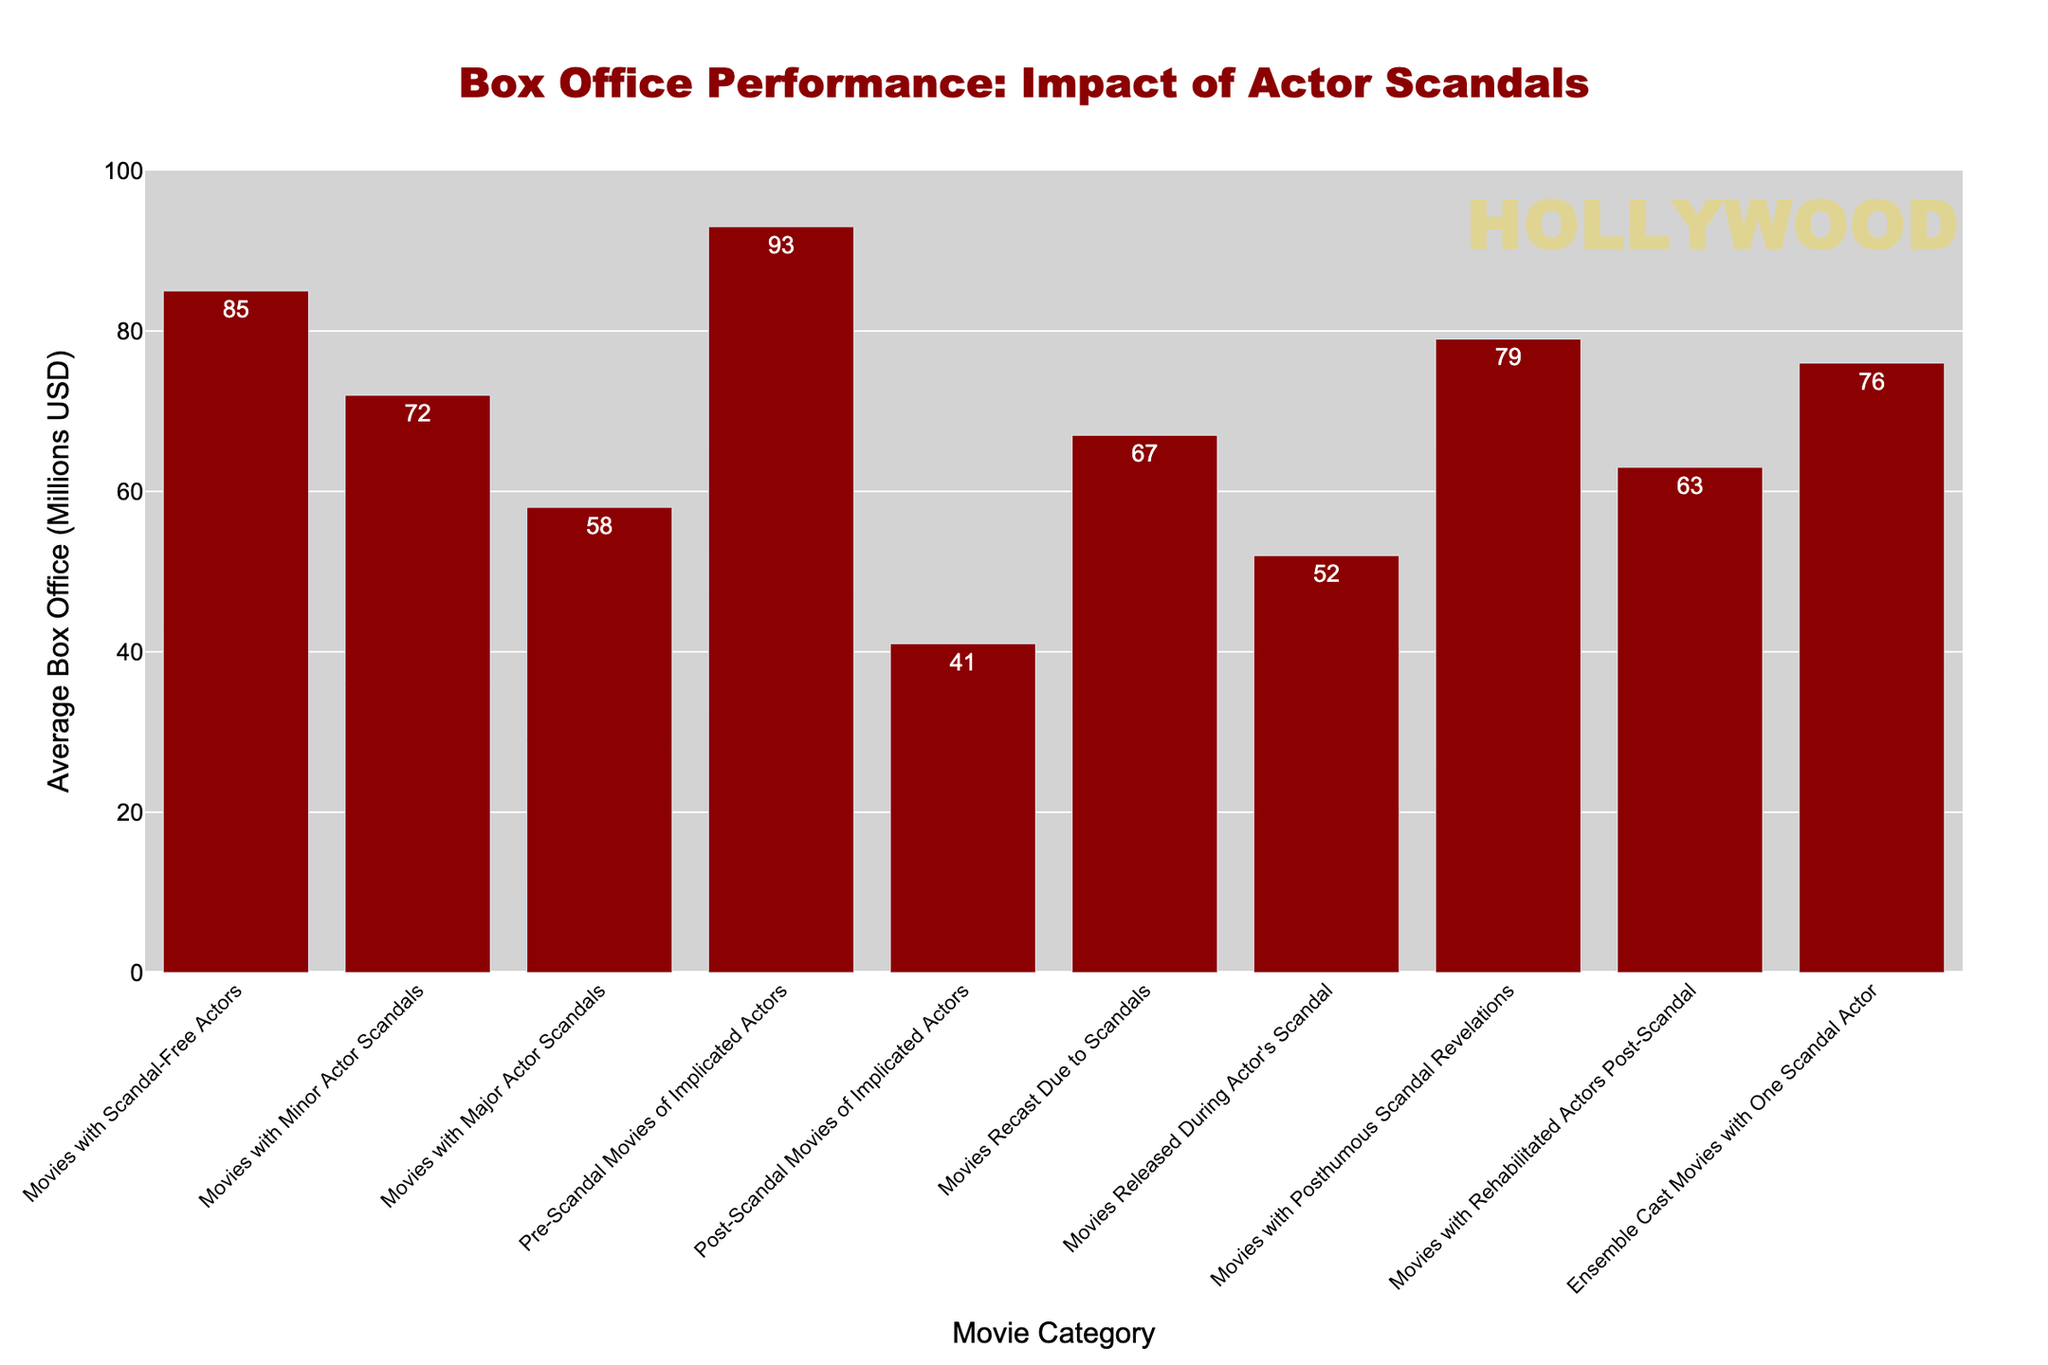Which movie category has the highest average box office? By referring to the height of the bars, the "Pre-Scandal Movies of Implicated Actors" category has the tallest bar indicating it has the highest average box office performance.
Answer: Pre-Scandal Movies of Implicated Actors Which category has a lower average box office, "Movies with Major Actor Scandals" or "Movies with Minor Actor Scandals"? Comparing the heights of the bars, "Movies with Major Actor Scandals" has a lower average box office than "Movies with Minor Actor Scandals."
Answer: Movies with Major Actor Scandals What's the difference in average box office between "Pre-Scandal Movies of Implicated Actors" and "Post-Scandal Movies of Implicated Actors"? The average box office for "Pre-Scandal Movies of Implicated Actors" is 93 million USD, and for "Post-Scandal Movies of Implicated Actors" it is 41 million USD. The difference is 93 - 41 = 52 million USD.
Answer: 52 million USD Among "Movies Recast Due to Scandals," "Movies Released During Actor's Scandal," and "Movies with Posthumous Scandal Revelations," which has the highest average box office? Comparing the heights of these three bars, "Movies with Posthumous Scandal Revelations" has the highest average box office.
Answer: Movies with Posthumous Scandal Revelations What's the average box office of all the categories combined? Sum of all categories' average box offices is 85 + 72 + 58 + 93 + 41 + 67 + 52 + 79 + 63 + 76 = 686. There are 10 categories, so the average is 686/10 = 68.6 million USD.
Answer: 68.6 million USD How much higher is the average box office of "Movies with Scandal-Free Actors" compared to "Movies Recast Due to Scandals"? The average box office for "Movies with Scandal-Free Actors" is 85 million USD, and for "Movies Recast Due to Scandals" it is 67 million USD. The difference is 85 - 67 = 18 million USD.
Answer: 18 million USD Which category has a higher average box office, "Ensemble Cast Movies with One Scandal Actor" or "Movies with Rehabilitated Actors Post-Scandal"? Comparing the heights of the bars, "Ensemble Cast Movies with One Scandal Actor" has a higher average box office than "Movies with Rehabilitated Actors Post-Scandal."
Answer: Ensemble Cast Movies with One Scandal Actor What can be inferred about the average box office for movies in the "Post-Scandal Movies of Implicated Actors" category? The average box office for "Post-Scandal Movies of Implicated Actors" is 41 million USD, which is among the lowest, indicating that scandals negatively impact the box office significantly.
Answer: Scandals negatively impact the box office What is the average box office difference between movies with scandal-free actors and those with actor scandals (both minor and major)? The average box office for scandal-free actors is 85 million USD, for minor scandals is 72 million USD, and for major scandals is 58 million USD. The differences are 85 - 72 = 13 million USD and 85 - 58 = 27 million USD, respectively.
Answer: 13 million USD and 27 million USD 